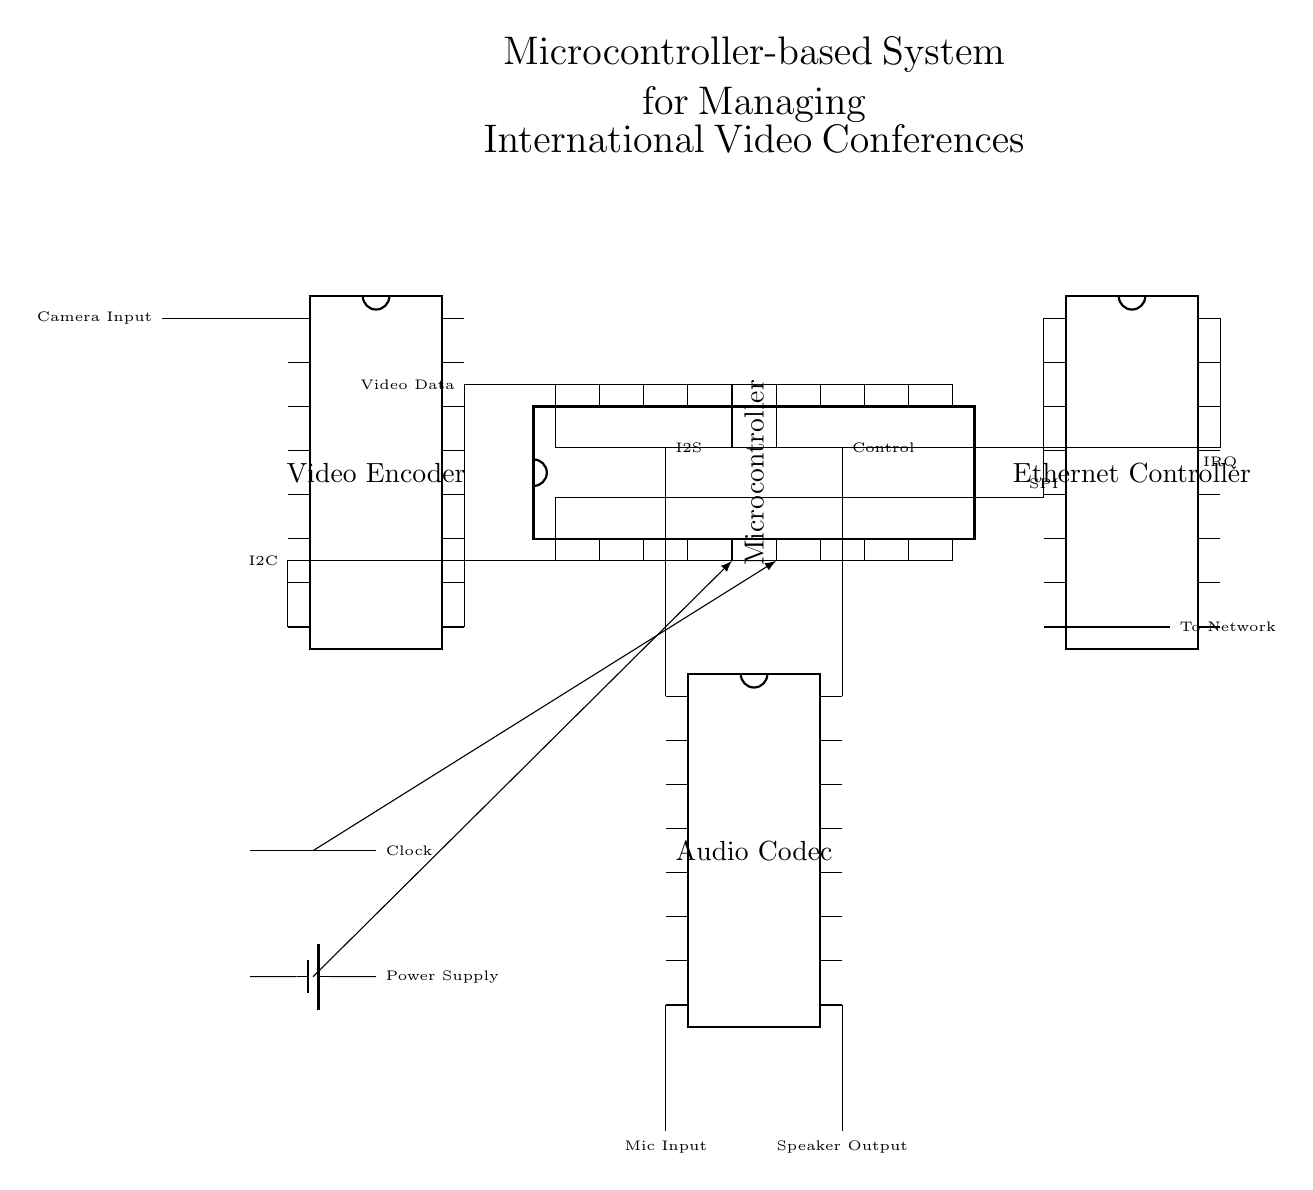What is the primary function of the microcontroller? The microcontroller primarily manages and controls the system operations, serving as the brain of the circuit. It interfaces with other components such as the Ethernet Controller, Video Encoder, and Audio Codec to facilitate the management of video conferences.
Answer: management and control Which component is used for capturing video? The Video Encoder is responsible for capturing and processing video input from the camera. It receives video data and encodes it for transmission over the network.
Answer: Video Encoder How many pins does the Ethernet Controller have? The Ethernet Controller has sixteen pins, as indicated in the circuit diagram.
Answer: sixteen What type of communication does the microcontroller use to connect with the audio codec? The microcontroller connects to the Audio Codec using I2S communication, which is specifically designed for digital audio data. This is shown in the label next to the connection line in the diagram.
Answer: I2S How is the camera input connected to the system? The camera input is connected to the Video Encoder, which processes the video signals. The connection is illustrated by an input line marked as "Camera Input" leading to the Video Encoder.
Answer: Video Encoder 